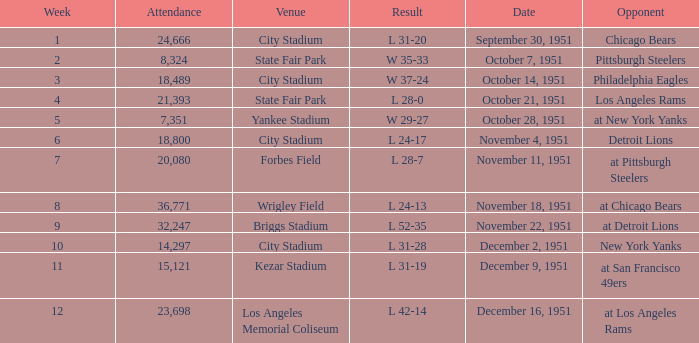Which venue hosted the Los Angeles Rams as an opponent? State Fair Park. 